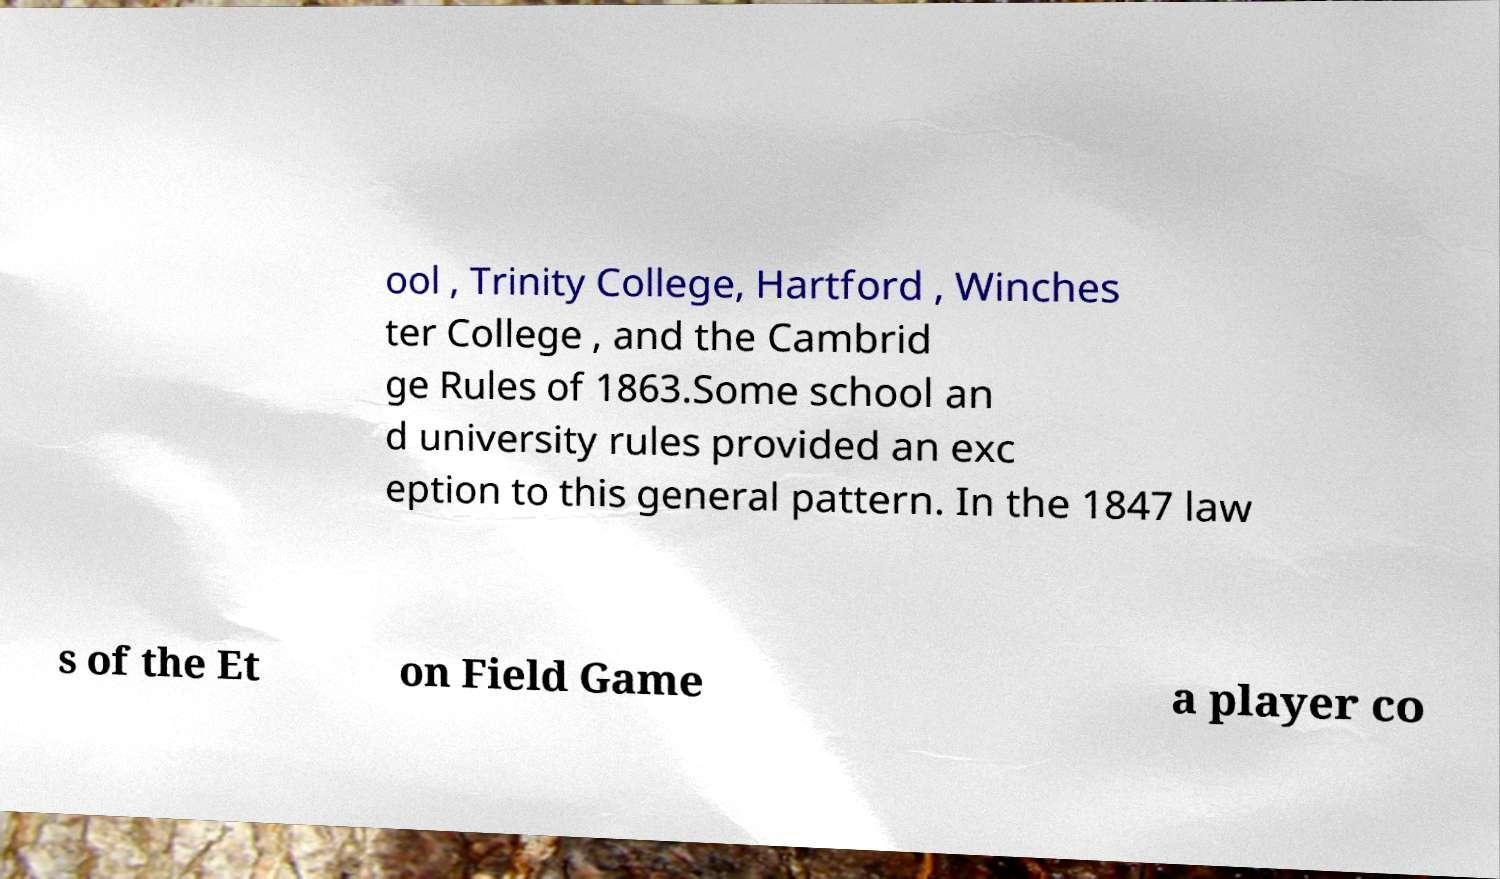There's text embedded in this image that I need extracted. Can you transcribe it verbatim? ool , Trinity College, Hartford , Winches ter College , and the Cambrid ge Rules of 1863.Some school an d university rules provided an exc eption to this general pattern. In the 1847 law s of the Et on Field Game a player co 